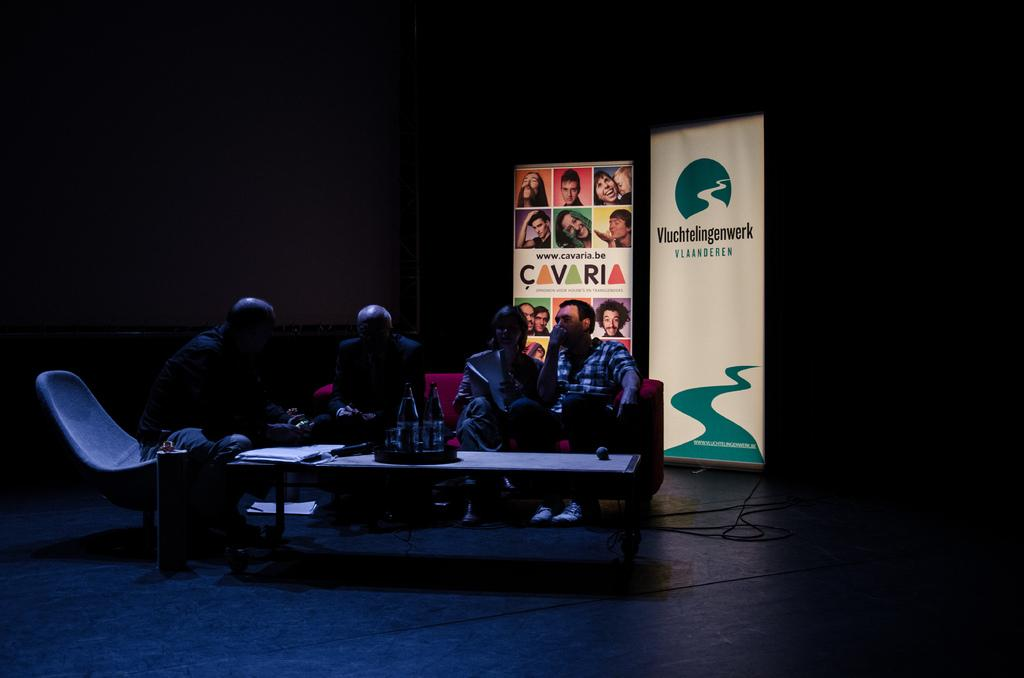How many people are in the image? There are four members in the image. What are the positions of the three people on the sofa? Three of them are sitting on a sofa. Where is the fourth person sitting? One person is sitting in a chair. What furniture is present in the image? There is a sofa and a chair in the image. What can be seen in the background of the image? There is an advertisement in the background. What type of plants are growing out of the person's pocket in the image? There are no plants growing out of anyone's pocket in the image. 